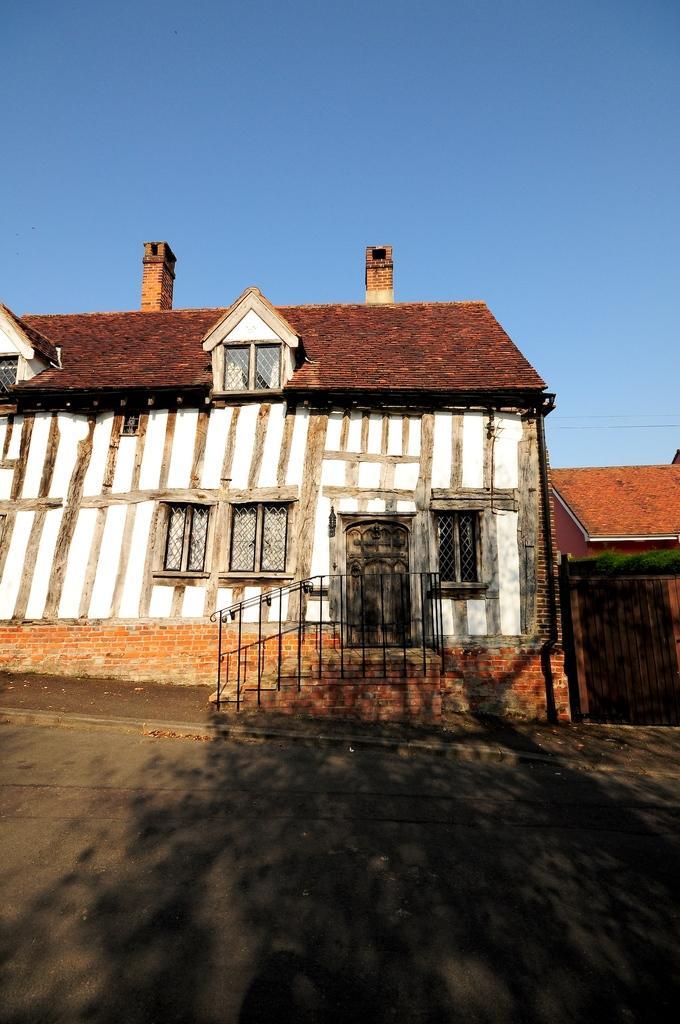Describe this image in one or two sentences. This image consists of a house along with the doors and windows. In the front, we can see the steps along with the railing. At the bottom, there is a road. At the top, we can see the roof and sky. 